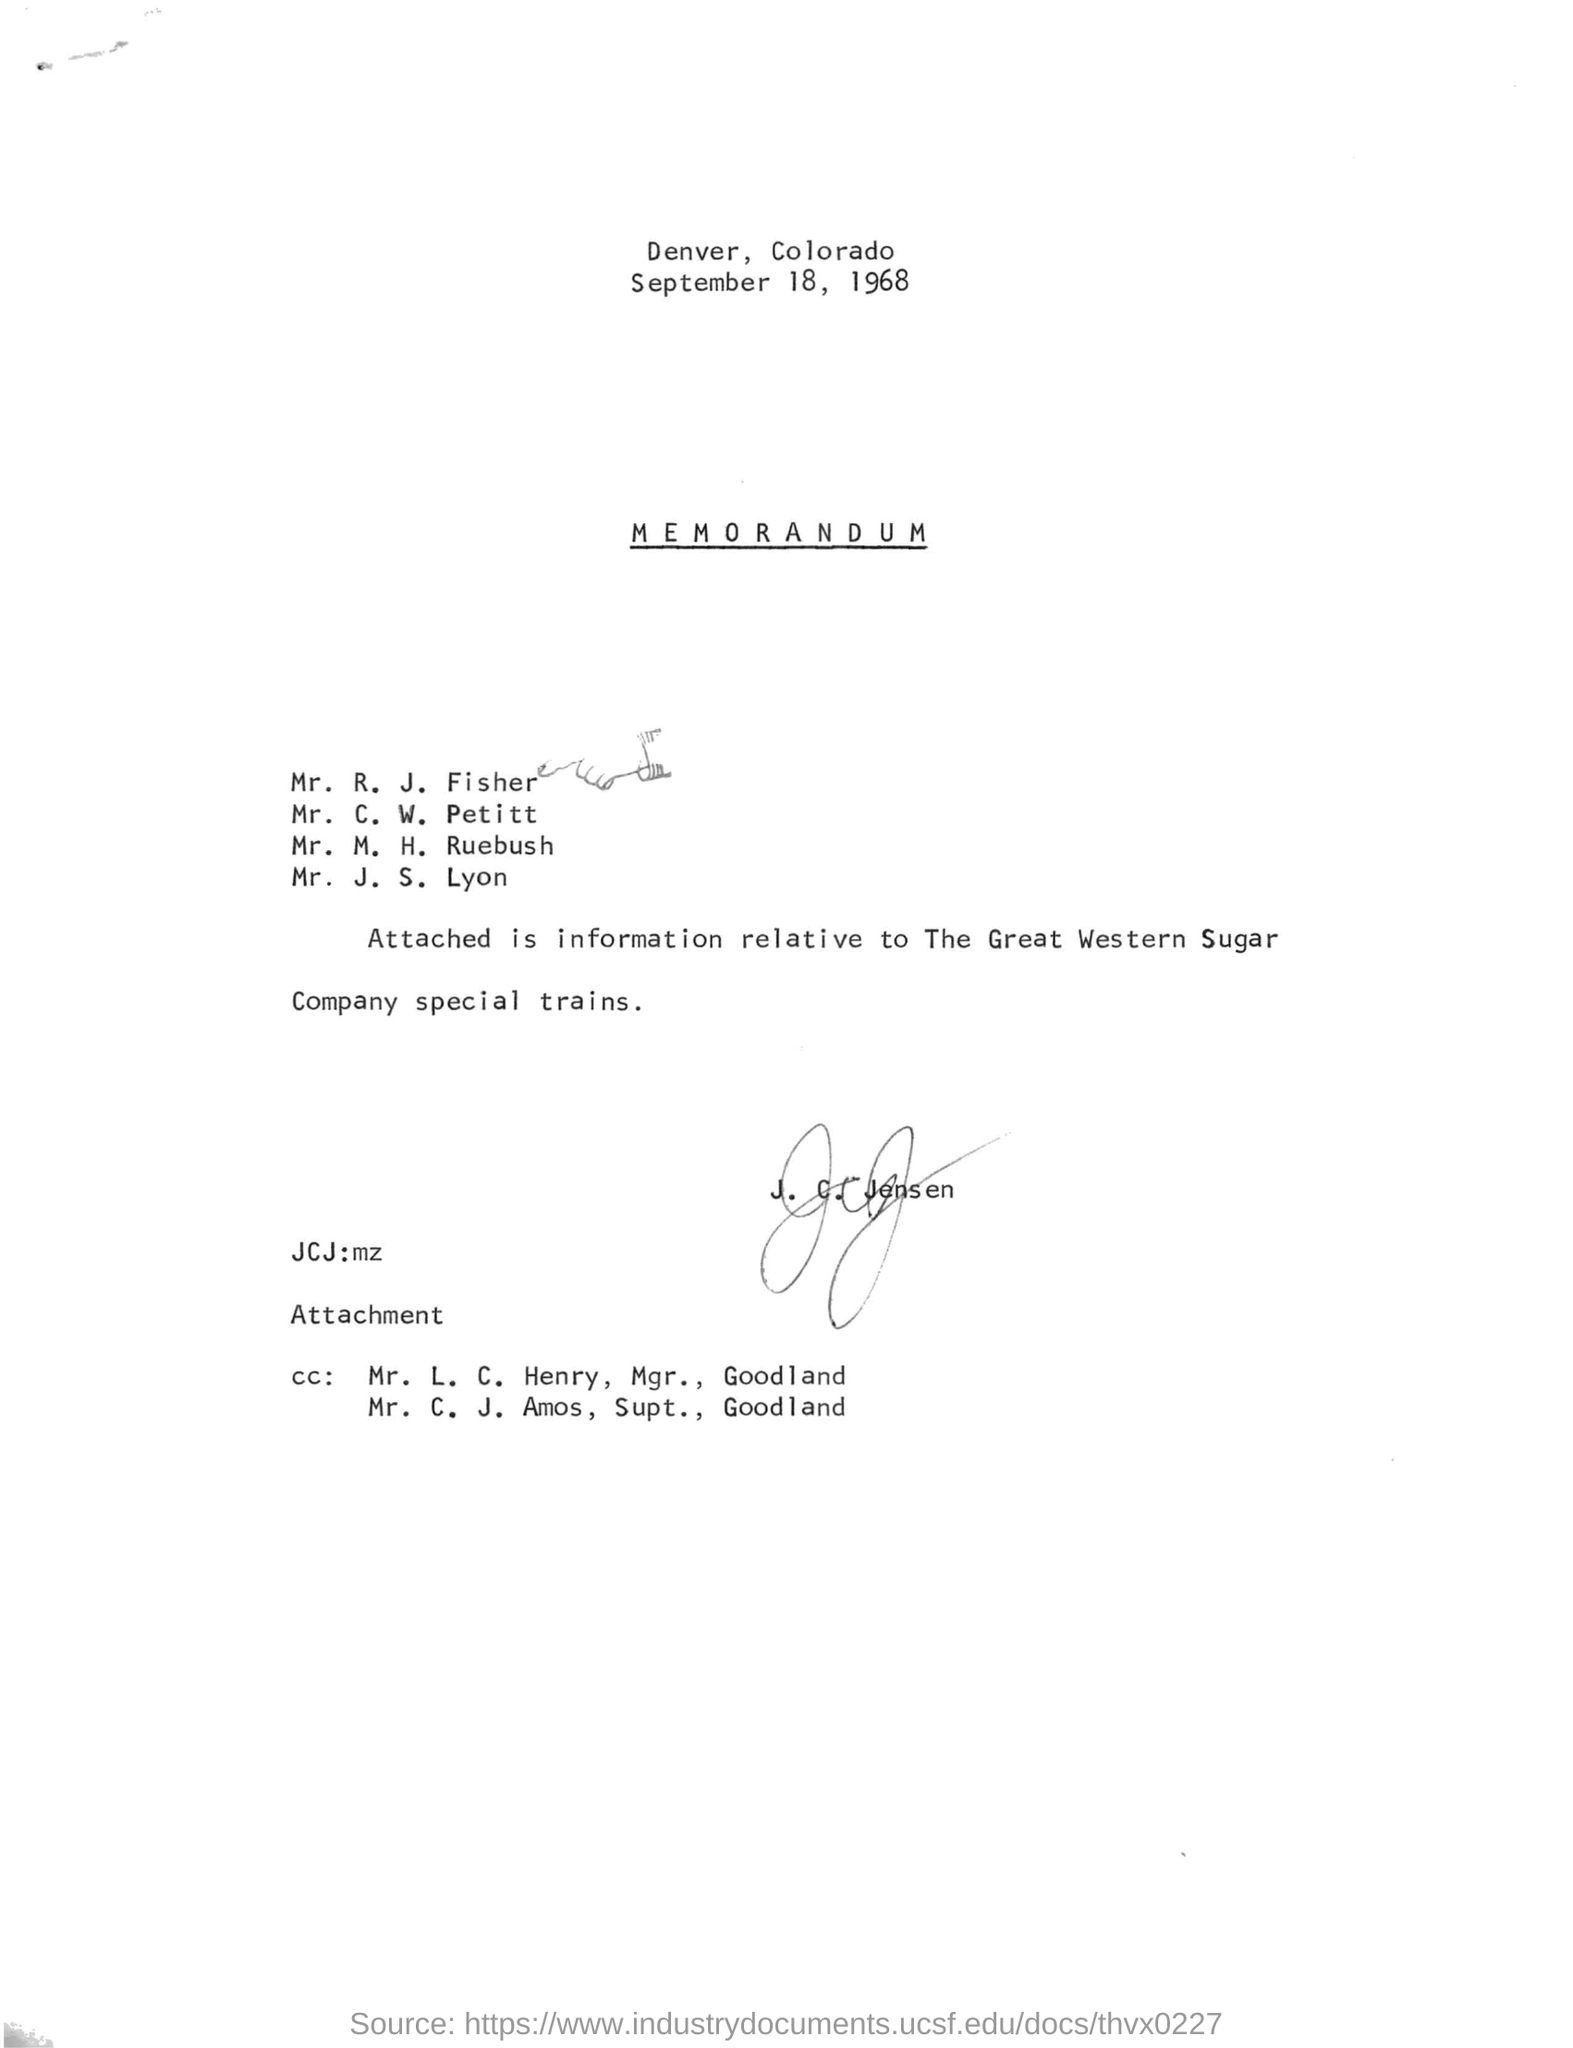What is the date in the memorandum?
Your response must be concise. September 18, 1968. 